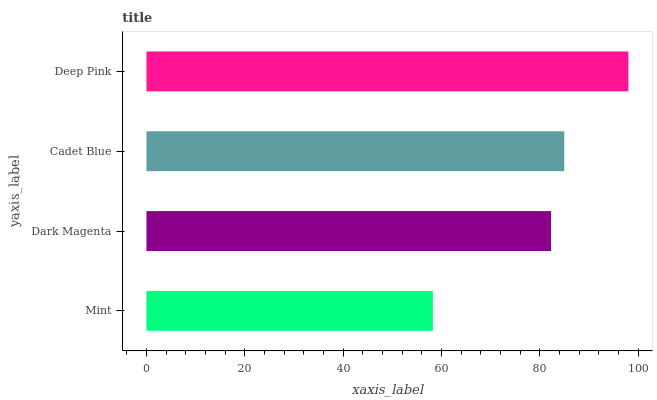Is Mint the minimum?
Answer yes or no. Yes. Is Deep Pink the maximum?
Answer yes or no. Yes. Is Dark Magenta the minimum?
Answer yes or no. No. Is Dark Magenta the maximum?
Answer yes or no. No. Is Dark Magenta greater than Mint?
Answer yes or no. Yes. Is Mint less than Dark Magenta?
Answer yes or no. Yes. Is Mint greater than Dark Magenta?
Answer yes or no. No. Is Dark Magenta less than Mint?
Answer yes or no. No. Is Cadet Blue the high median?
Answer yes or no. Yes. Is Dark Magenta the low median?
Answer yes or no. Yes. Is Mint the high median?
Answer yes or no. No. Is Mint the low median?
Answer yes or no. No. 